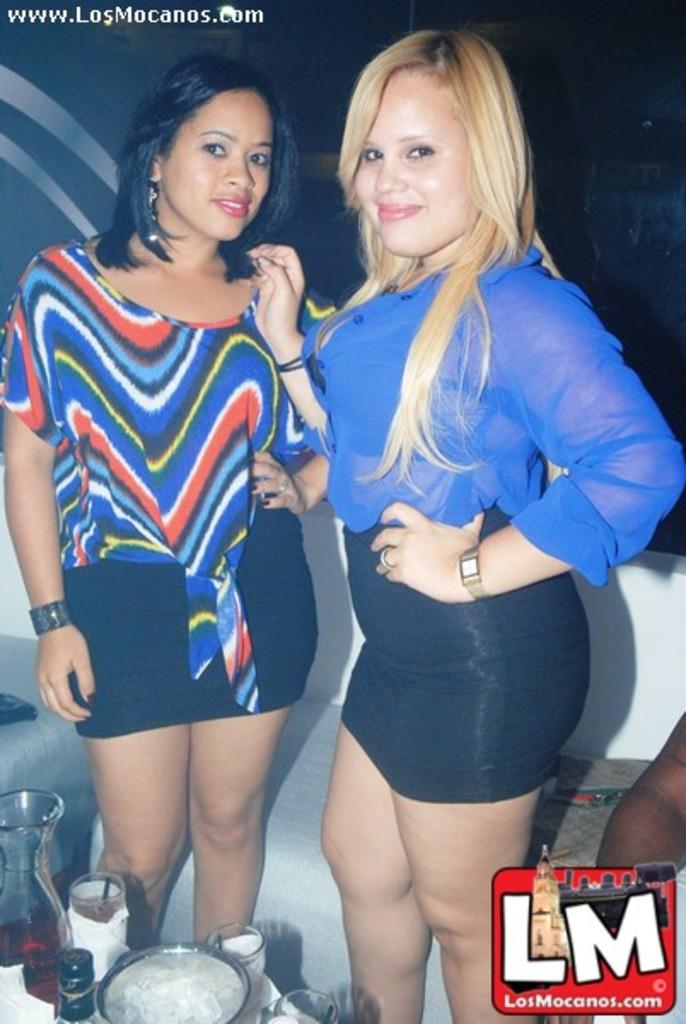<image>
Provide a brief description of the given image. A photo featuring two women is hosted on the LosMonacos website. 